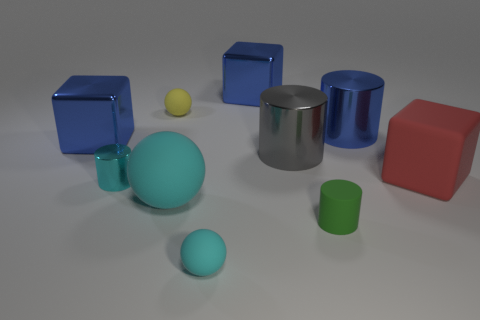If I wanted to arrange these objects by size, which one would be in the middle? If arranging the objects by size in ascending or descending order, the shiny metallic cylinder would be positioned in the middle. It's larger than the spheres and the small cylinder but smaller than the big cylinder and cubes. 